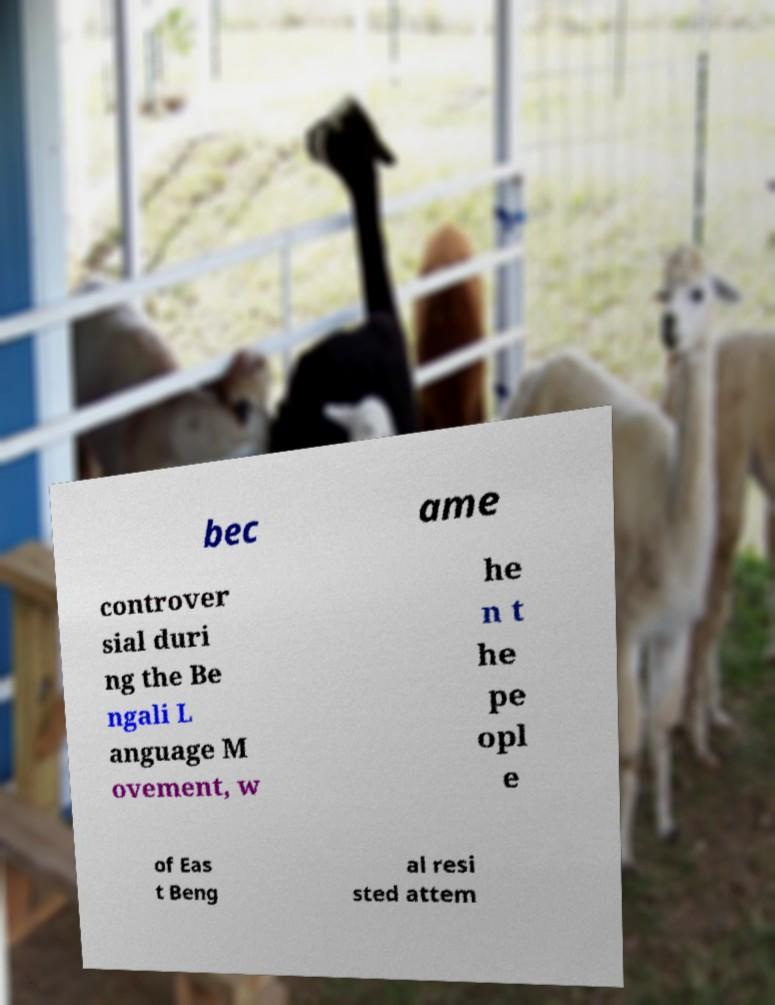Please read and relay the text visible in this image. What does it say? bec ame controver sial duri ng the Be ngali L anguage M ovement, w he n t he pe opl e of Eas t Beng al resi sted attem 